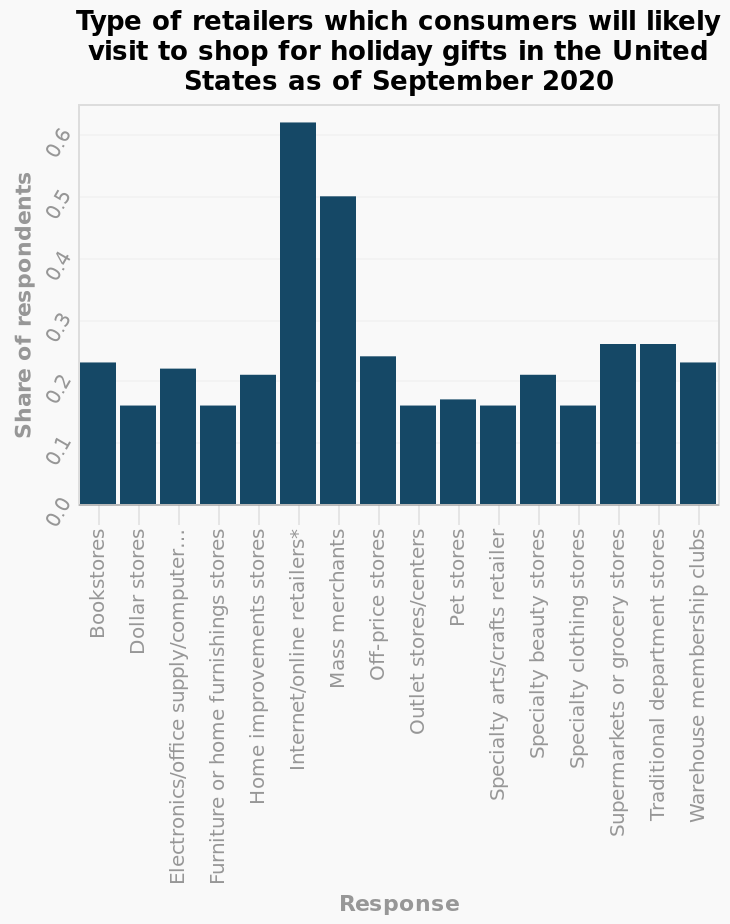<image>
What was the most popular way to purchase holiday gifts in September 2020? The most popular way to purchase holiday gifts in September 2020 was to buy from online retailers with over a 0.6 percentage share. What percentage share did online retailers have in the purchase of holiday gifts in September 2020? Online retailers had over a 0.6 percentage share in the purchase of holiday gifts in September 2020. Describe the following image in detail This bar diagram is labeled Type of retailers which consumers will likely visit to shop for holiday gifts in the United States as of September 2020. The y-axis measures Share of respondents along scale from 0.0 to 0.6 while the x-axis measures Response along categorical scale starting with Bookstores and ending with Warehouse membership clubs. What does the y-axis measure on the bar diagram? The y-axis measures the Share of respondents along a scale from 0.0 to 0.6. 